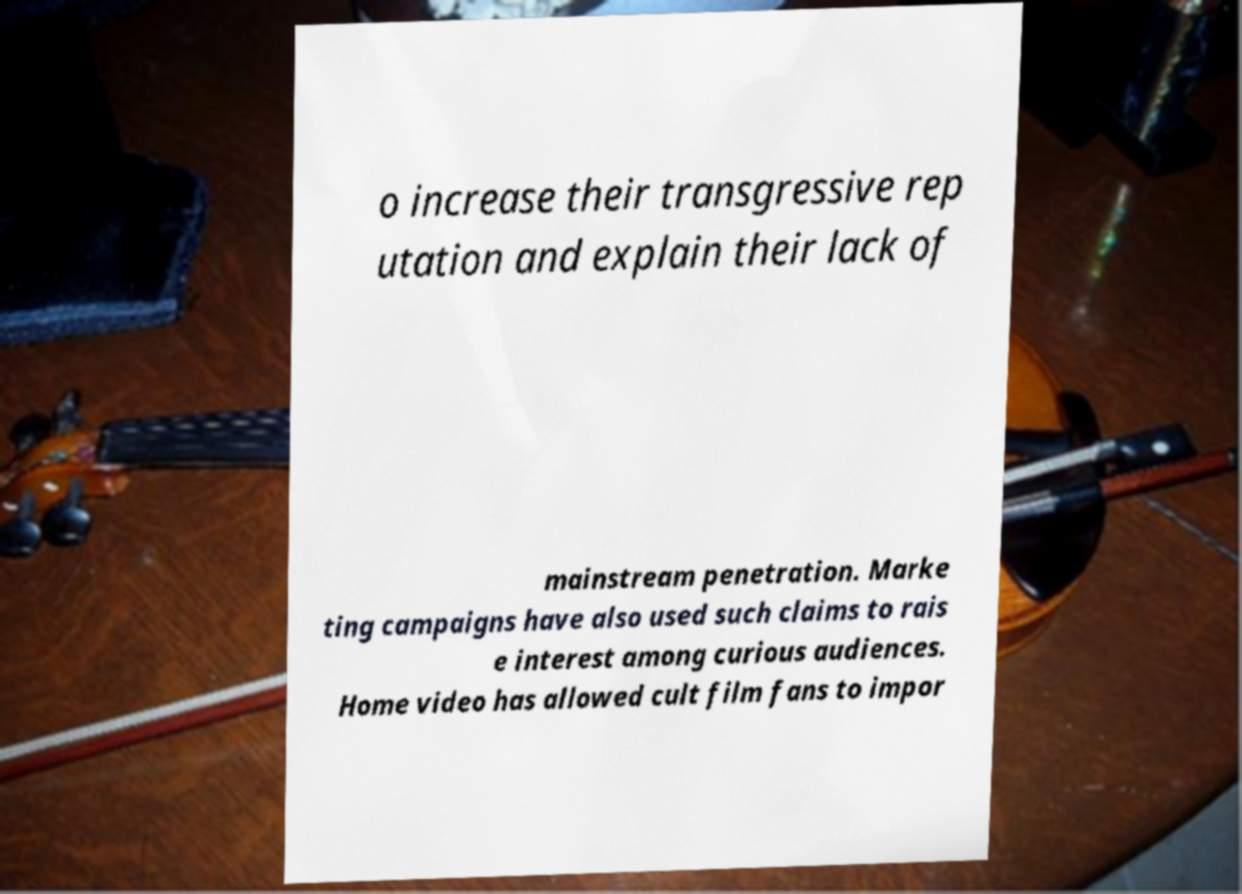Can you accurately transcribe the text from the provided image for me? o increase their transgressive rep utation and explain their lack of mainstream penetration. Marke ting campaigns have also used such claims to rais e interest among curious audiences. Home video has allowed cult film fans to impor 